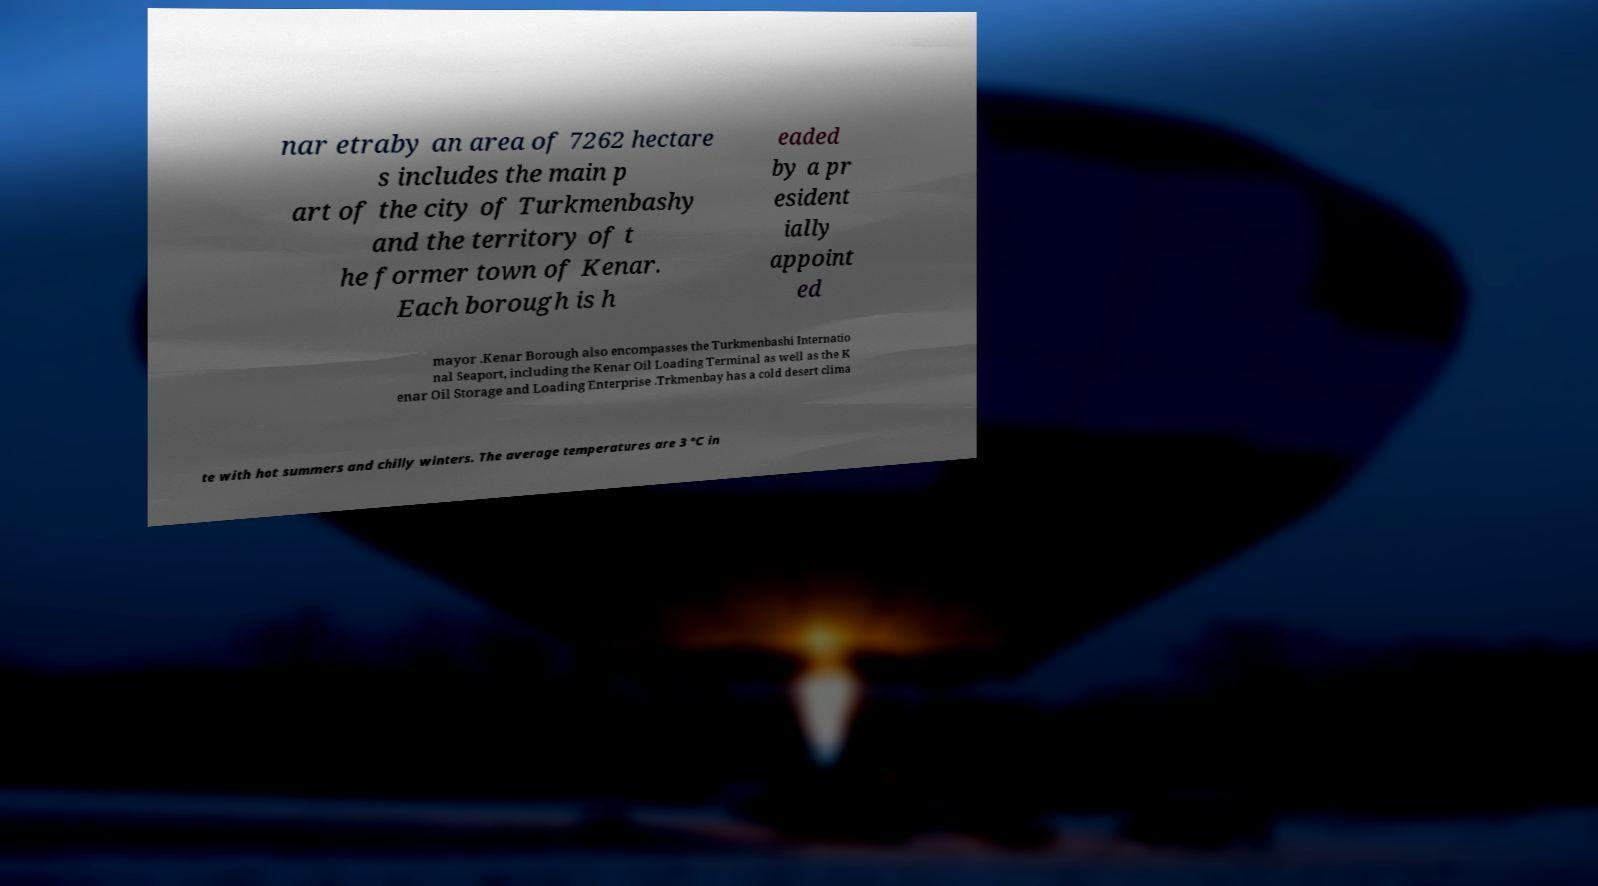I need the written content from this picture converted into text. Can you do that? nar etraby an area of 7262 hectare s includes the main p art of the city of Turkmenbashy and the territory of t he former town of Kenar. Each borough is h eaded by a pr esident ially appoint ed mayor .Kenar Borough also encompasses the Turkmenbashi Internatio nal Seaport, including the Kenar Oil Loading Terminal as well as the K enar Oil Storage and Loading Enterprise .Trkmenbay has a cold desert clima te with hot summers and chilly winters. The average temperatures are 3 °C in 